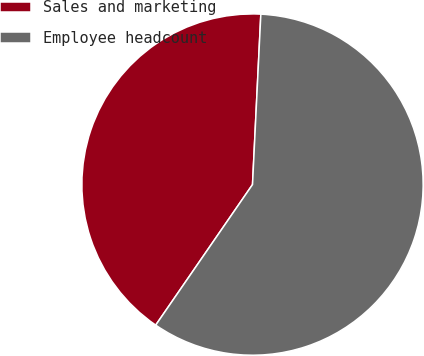<chart> <loc_0><loc_0><loc_500><loc_500><pie_chart><fcel>Sales and marketing<fcel>Employee headcount<nl><fcel>41.18%<fcel>58.82%<nl></chart> 